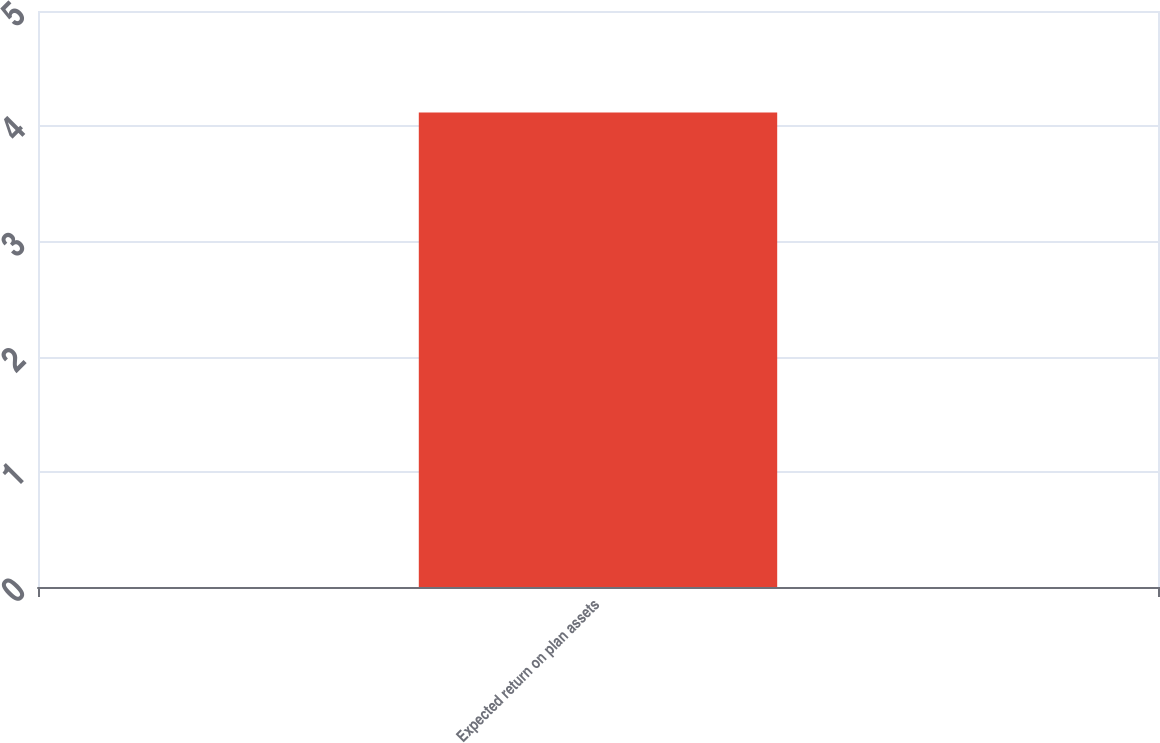<chart> <loc_0><loc_0><loc_500><loc_500><bar_chart><fcel>Expected return on plan assets<nl><fcel>4.12<nl></chart> 